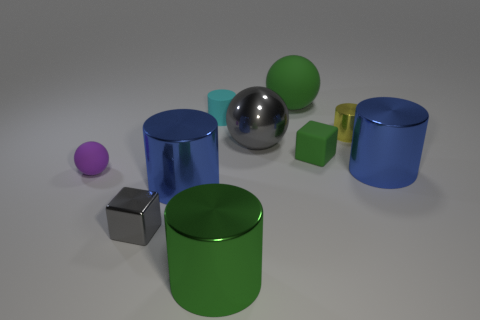Subtract all green cylinders. How many cylinders are left? 4 Subtract all matte cylinders. How many cylinders are left? 4 Subtract all gray cylinders. Subtract all cyan balls. How many cylinders are left? 5 Subtract all spheres. How many objects are left? 7 Subtract 0 purple cylinders. How many objects are left? 10 Subtract all metallic objects. Subtract all small purple rubber balls. How many objects are left? 3 Add 8 tiny cyan rubber objects. How many tiny cyan rubber objects are left? 9 Add 1 tiny brown matte things. How many tiny brown matte things exist? 1 